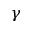<formula> <loc_0><loc_0><loc_500><loc_500>\gamma</formula> 